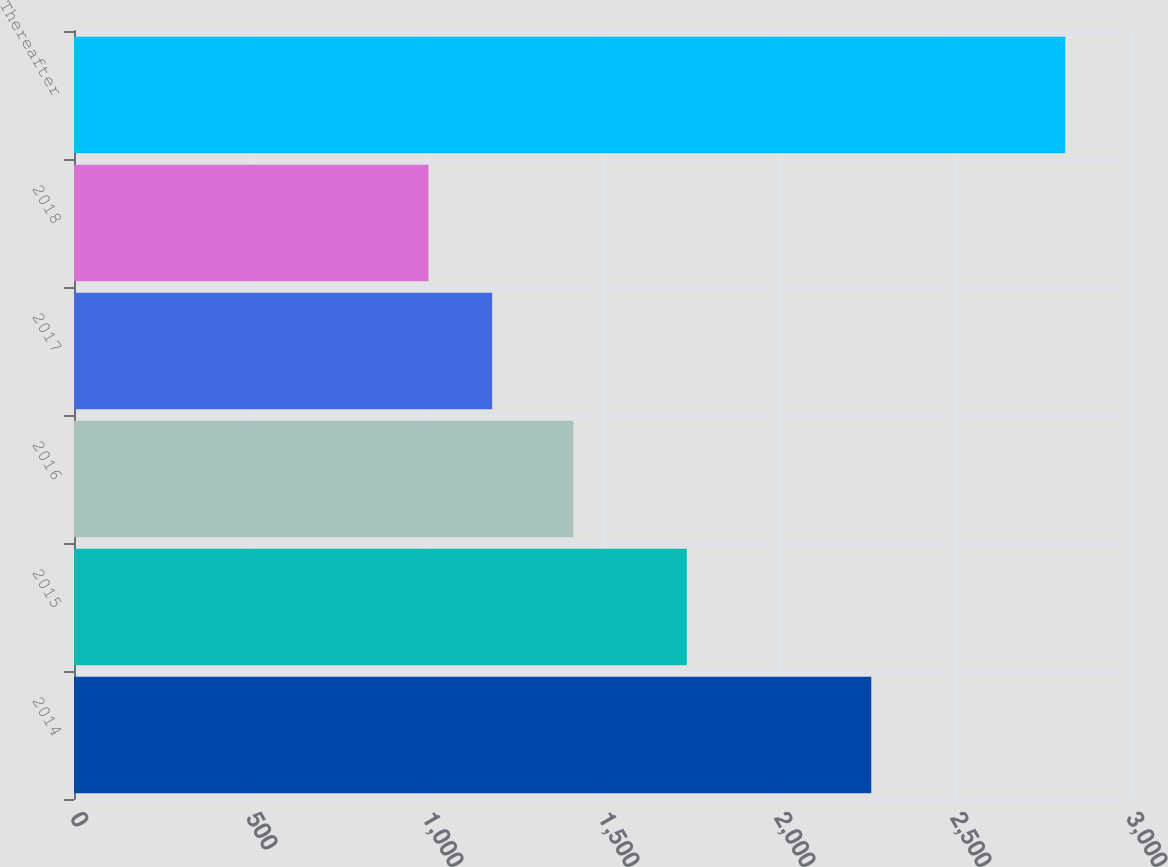Convert chart. <chart><loc_0><loc_0><loc_500><loc_500><bar_chart><fcel>2014<fcel>2015<fcel>2016<fcel>2017<fcel>2018<fcel>Thereafter<nl><fcel>2265<fcel>1741<fcel>1419<fcel>1187.9<fcel>1007<fcel>2816<nl></chart> 